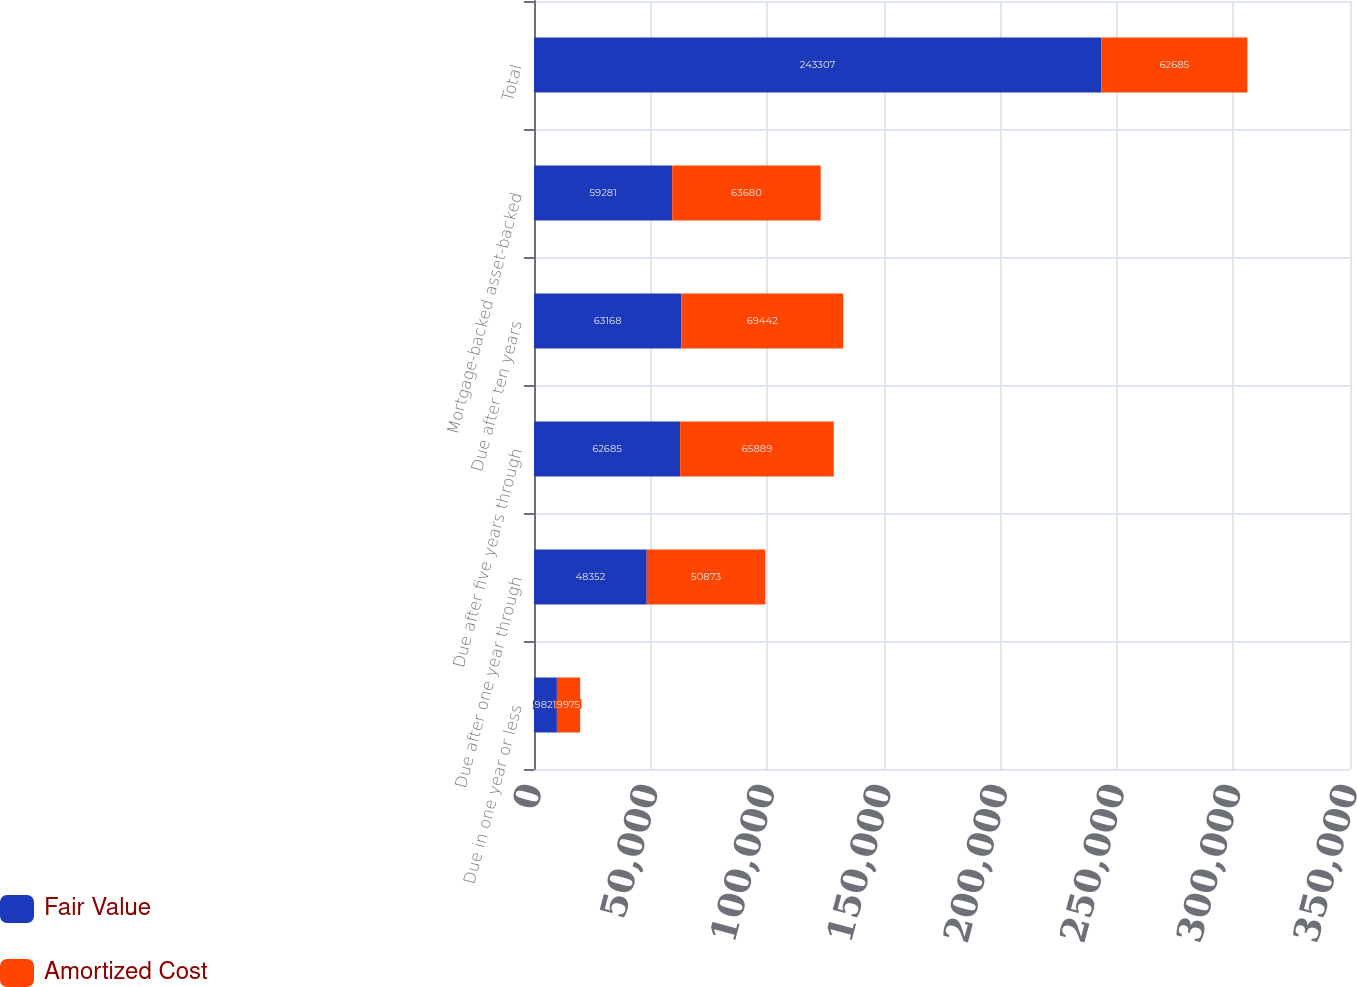<chart> <loc_0><loc_0><loc_500><loc_500><stacked_bar_chart><ecel><fcel>Due in one year or less<fcel>Due after one year through<fcel>Due after five years through<fcel>Due after ten years<fcel>Mortgage-backed asset-backed<fcel>Total<nl><fcel>Fair Value<fcel>9821<fcel>48352<fcel>62685<fcel>63168<fcel>59281<fcel>243307<nl><fcel>Amortized Cost<fcel>9975<fcel>50873<fcel>65889<fcel>69442<fcel>63680<fcel>62685<nl></chart> 